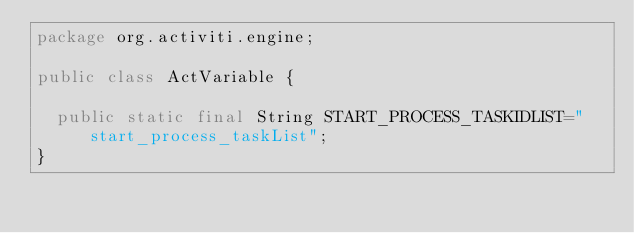Convert code to text. <code><loc_0><loc_0><loc_500><loc_500><_Java_>package org.activiti.engine;

public class ActVariable {

	public static final String START_PROCESS_TASKIDLIST="start_process_taskList";
}
</code> 